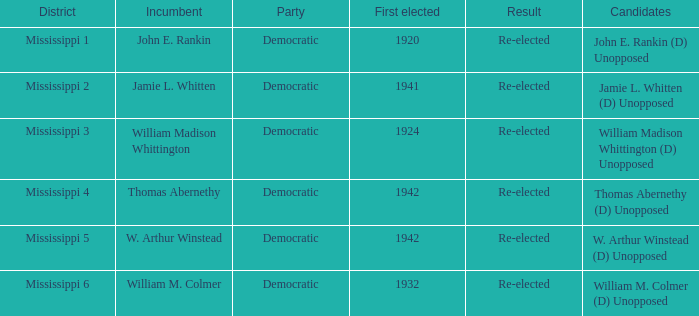What is the incumbent from 1941? Jamie L. Whitten. 